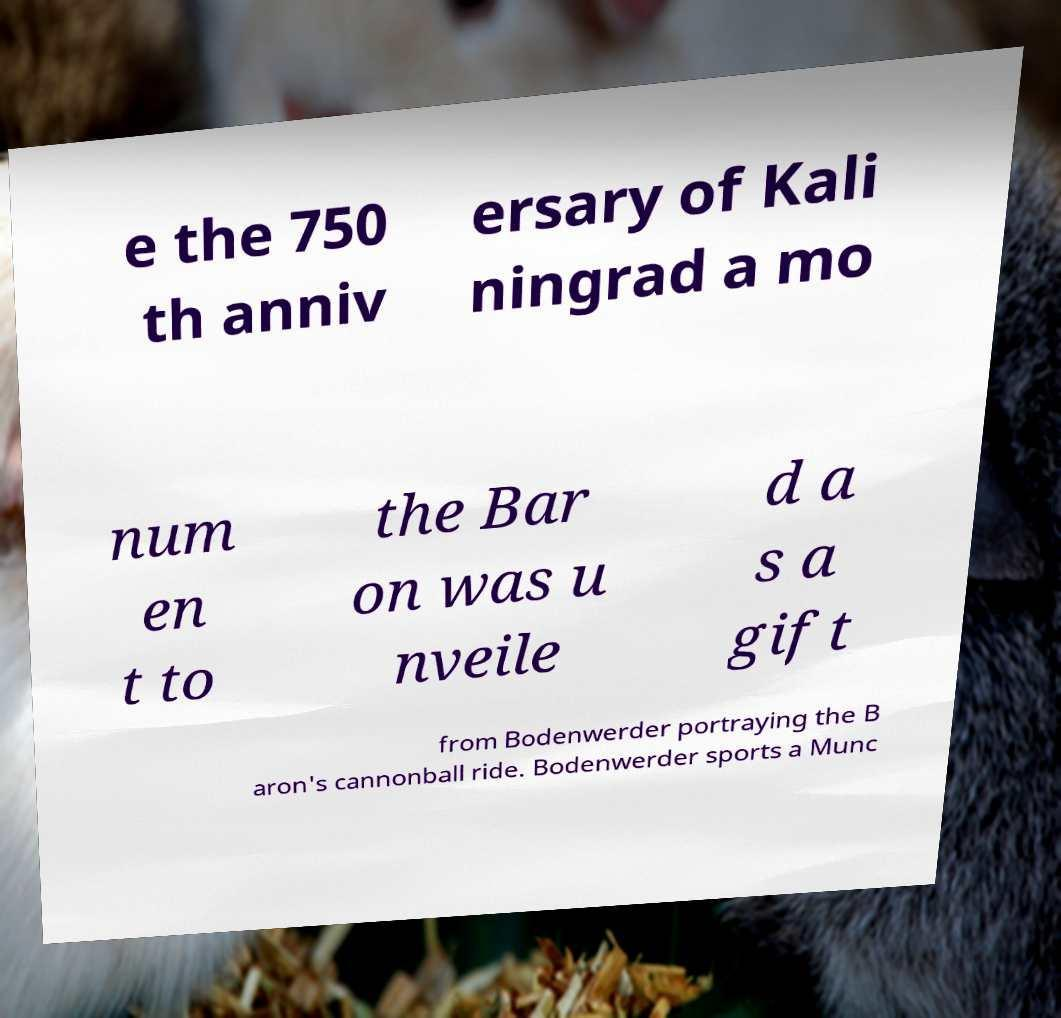What messages or text are displayed in this image? I need them in a readable, typed format. e the 750 th anniv ersary of Kali ningrad a mo num en t to the Bar on was u nveile d a s a gift from Bodenwerder portraying the B aron's cannonball ride. Bodenwerder sports a Munc 